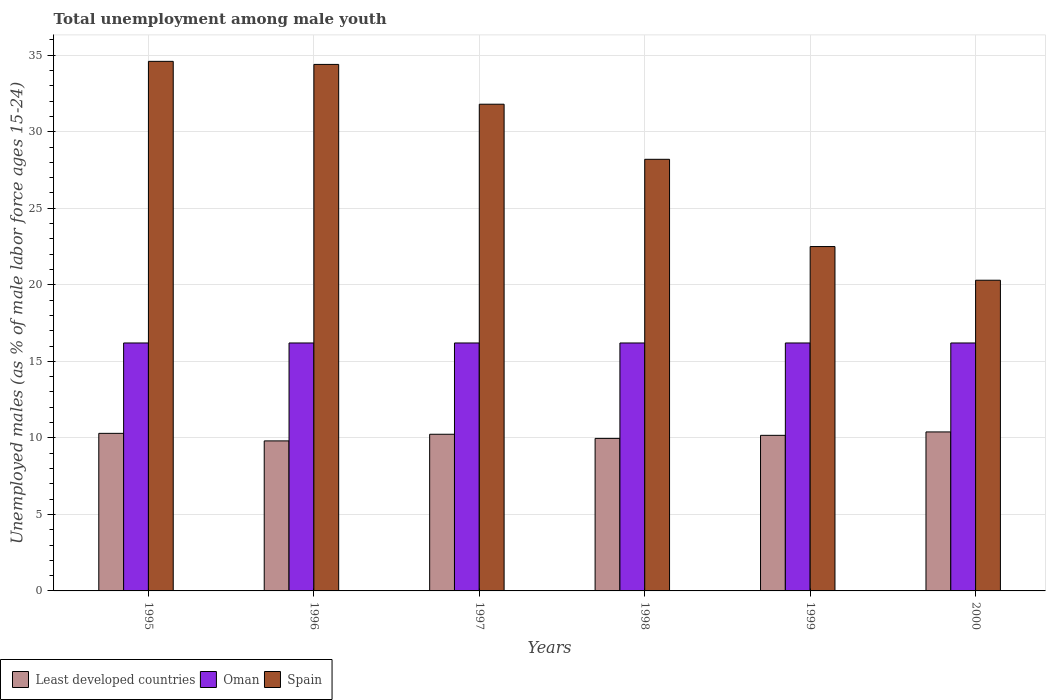What is the percentage of unemployed males in in Least developed countries in 1998?
Your answer should be compact. 9.97. Across all years, what is the maximum percentage of unemployed males in in Least developed countries?
Ensure brevity in your answer.  10.39. Across all years, what is the minimum percentage of unemployed males in in Least developed countries?
Offer a terse response. 9.8. What is the total percentage of unemployed males in in Oman in the graph?
Ensure brevity in your answer.  97.2. What is the difference between the percentage of unemployed males in in Least developed countries in 1995 and that in 2000?
Your response must be concise. -0.09. What is the difference between the percentage of unemployed males in in Oman in 1997 and the percentage of unemployed males in in Least developed countries in 1998?
Ensure brevity in your answer.  6.23. What is the average percentage of unemployed males in in Oman per year?
Your answer should be compact. 16.2. In the year 1996, what is the difference between the percentage of unemployed males in in Oman and percentage of unemployed males in in Least developed countries?
Your response must be concise. 6.4. In how many years, is the percentage of unemployed males in in Spain greater than 9 %?
Ensure brevity in your answer.  6. What is the ratio of the percentage of unemployed males in in Least developed countries in 1995 to that in 1998?
Provide a succinct answer. 1.03. Is the percentage of unemployed males in in Spain in 1997 less than that in 2000?
Your answer should be very brief. No. What is the difference between the highest and the second highest percentage of unemployed males in in Spain?
Provide a short and direct response. 0.2. What is the difference between the highest and the lowest percentage of unemployed males in in Least developed countries?
Your answer should be very brief. 0.59. Is the sum of the percentage of unemployed males in in Spain in 1998 and 2000 greater than the maximum percentage of unemployed males in in Oman across all years?
Your answer should be compact. Yes. What does the 2nd bar from the left in 1998 represents?
Make the answer very short. Oman. What does the 3rd bar from the right in 1999 represents?
Keep it short and to the point. Least developed countries. Does the graph contain grids?
Provide a succinct answer. Yes. How are the legend labels stacked?
Keep it short and to the point. Horizontal. What is the title of the graph?
Offer a very short reply. Total unemployment among male youth. Does "Rwanda" appear as one of the legend labels in the graph?
Your response must be concise. No. What is the label or title of the X-axis?
Your answer should be compact. Years. What is the label or title of the Y-axis?
Ensure brevity in your answer.  Unemployed males (as % of male labor force ages 15-24). What is the Unemployed males (as % of male labor force ages 15-24) in Least developed countries in 1995?
Offer a terse response. 10.3. What is the Unemployed males (as % of male labor force ages 15-24) in Oman in 1995?
Make the answer very short. 16.2. What is the Unemployed males (as % of male labor force ages 15-24) of Spain in 1995?
Offer a very short reply. 34.6. What is the Unemployed males (as % of male labor force ages 15-24) in Least developed countries in 1996?
Provide a succinct answer. 9.8. What is the Unemployed males (as % of male labor force ages 15-24) of Oman in 1996?
Make the answer very short. 16.2. What is the Unemployed males (as % of male labor force ages 15-24) in Spain in 1996?
Offer a terse response. 34.4. What is the Unemployed males (as % of male labor force ages 15-24) in Least developed countries in 1997?
Provide a succinct answer. 10.24. What is the Unemployed males (as % of male labor force ages 15-24) in Oman in 1997?
Provide a short and direct response. 16.2. What is the Unemployed males (as % of male labor force ages 15-24) of Spain in 1997?
Your answer should be very brief. 31.8. What is the Unemployed males (as % of male labor force ages 15-24) in Least developed countries in 1998?
Keep it short and to the point. 9.97. What is the Unemployed males (as % of male labor force ages 15-24) in Oman in 1998?
Ensure brevity in your answer.  16.2. What is the Unemployed males (as % of male labor force ages 15-24) of Spain in 1998?
Keep it short and to the point. 28.2. What is the Unemployed males (as % of male labor force ages 15-24) of Least developed countries in 1999?
Ensure brevity in your answer.  10.17. What is the Unemployed males (as % of male labor force ages 15-24) in Oman in 1999?
Offer a terse response. 16.2. What is the Unemployed males (as % of male labor force ages 15-24) in Least developed countries in 2000?
Ensure brevity in your answer.  10.39. What is the Unemployed males (as % of male labor force ages 15-24) of Oman in 2000?
Your response must be concise. 16.2. What is the Unemployed males (as % of male labor force ages 15-24) of Spain in 2000?
Your answer should be compact. 20.3. Across all years, what is the maximum Unemployed males (as % of male labor force ages 15-24) in Least developed countries?
Your answer should be very brief. 10.39. Across all years, what is the maximum Unemployed males (as % of male labor force ages 15-24) in Oman?
Keep it short and to the point. 16.2. Across all years, what is the maximum Unemployed males (as % of male labor force ages 15-24) in Spain?
Give a very brief answer. 34.6. Across all years, what is the minimum Unemployed males (as % of male labor force ages 15-24) in Least developed countries?
Provide a short and direct response. 9.8. Across all years, what is the minimum Unemployed males (as % of male labor force ages 15-24) in Oman?
Provide a succinct answer. 16.2. Across all years, what is the minimum Unemployed males (as % of male labor force ages 15-24) in Spain?
Provide a succinct answer. 20.3. What is the total Unemployed males (as % of male labor force ages 15-24) in Least developed countries in the graph?
Your answer should be very brief. 60.85. What is the total Unemployed males (as % of male labor force ages 15-24) in Oman in the graph?
Your response must be concise. 97.2. What is the total Unemployed males (as % of male labor force ages 15-24) in Spain in the graph?
Provide a short and direct response. 171.8. What is the difference between the Unemployed males (as % of male labor force ages 15-24) of Least developed countries in 1995 and that in 1996?
Ensure brevity in your answer.  0.49. What is the difference between the Unemployed males (as % of male labor force ages 15-24) in Oman in 1995 and that in 1996?
Provide a short and direct response. 0. What is the difference between the Unemployed males (as % of male labor force ages 15-24) of Least developed countries in 1995 and that in 1997?
Your answer should be compact. 0.06. What is the difference between the Unemployed males (as % of male labor force ages 15-24) in Oman in 1995 and that in 1997?
Your answer should be compact. 0. What is the difference between the Unemployed males (as % of male labor force ages 15-24) in Least developed countries in 1995 and that in 1998?
Your answer should be compact. 0.33. What is the difference between the Unemployed males (as % of male labor force ages 15-24) of Least developed countries in 1995 and that in 1999?
Your response must be concise. 0.13. What is the difference between the Unemployed males (as % of male labor force ages 15-24) in Spain in 1995 and that in 1999?
Give a very brief answer. 12.1. What is the difference between the Unemployed males (as % of male labor force ages 15-24) of Least developed countries in 1995 and that in 2000?
Keep it short and to the point. -0.09. What is the difference between the Unemployed males (as % of male labor force ages 15-24) in Spain in 1995 and that in 2000?
Give a very brief answer. 14.3. What is the difference between the Unemployed males (as % of male labor force ages 15-24) in Least developed countries in 1996 and that in 1997?
Offer a terse response. -0.43. What is the difference between the Unemployed males (as % of male labor force ages 15-24) in Oman in 1996 and that in 1997?
Keep it short and to the point. 0. What is the difference between the Unemployed males (as % of male labor force ages 15-24) in Spain in 1996 and that in 1997?
Keep it short and to the point. 2.6. What is the difference between the Unemployed males (as % of male labor force ages 15-24) in Least developed countries in 1996 and that in 1998?
Provide a short and direct response. -0.16. What is the difference between the Unemployed males (as % of male labor force ages 15-24) in Spain in 1996 and that in 1998?
Your response must be concise. 6.2. What is the difference between the Unemployed males (as % of male labor force ages 15-24) in Least developed countries in 1996 and that in 1999?
Your answer should be compact. -0.36. What is the difference between the Unemployed males (as % of male labor force ages 15-24) of Oman in 1996 and that in 1999?
Your response must be concise. 0. What is the difference between the Unemployed males (as % of male labor force ages 15-24) of Spain in 1996 and that in 1999?
Provide a short and direct response. 11.9. What is the difference between the Unemployed males (as % of male labor force ages 15-24) of Least developed countries in 1996 and that in 2000?
Give a very brief answer. -0.59. What is the difference between the Unemployed males (as % of male labor force ages 15-24) of Least developed countries in 1997 and that in 1998?
Offer a terse response. 0.27. What is the difference between the Unemployed males (as % of male labor force ages 15-24) in Spain in 1997 and that in 1998?
Your response must be concise. 3.6. What is the difference between the Unemployed males (as % of male labor force ages 15-24) of Least developed countries in 1997 and that in 1999?
Give a very brief answer. 0.07. What is the difference between the Unemployed males (as % of male labor force ages 15-24) in Oman in 1997 and that in 1999?
Ensure brevity in your answer.  0. What is the difference between the Unemployed males (as % of male labor force ages 15-24) of Spain in 1997 and that in 1999?
Keep it short and to the point. 9.3. What is the difference between the Unemployed males (as % of male labor force ages 15-24) of Least developed countries in 1997 and that in 2000?
Provide a short and direct response. -0.15. What is the difference between the Unemployed males (as % of male labor force ages 15-24) in Oman in 1997 and that in 2000?
Make the answer very short. 0. What is the difference between the Unemployed males (as % of male labor force ages 15-24) in Least developed countries in 1998 and that in 1999?
Provide a succinct answer. -0.2. What is the difference between the Unemployed males (as % of male labor force ages 15-24) of Oman in 1998 and that in 1999?
Your response must be concise. 0. What is the difference between the Unemployed males (as % of male labor force ages 15-24) of Spain in 1998 and that in 1999?
Your answer should be very brief. 5.7. What is the difference between the Unemployed males (as % of male labor force ages 15-24) in Least developed countries in 1998 and that in 2000?
Offer a terse response. -0.42. What is the difference between the Unemployed males (as % of male labor force ages 15-24) of Oman in 1998 and that in 2000?
Give a very brief answer. 0. What is the difference between the Unemployed males (as % of male labor force ages 15-24) of Spain in 1998 and that in 2000?
Make the answer very short. 7.9. What is the difference between the Unemployed males (as % of male labor force ages 15-24) of Least developed countries in 1999 and that in 2000?
Make the answer very short. -0.22. What is the difference between the Unemployed males (as % of male labor force ages 15-24) of Oman in 1999 and that in 2000?
Your answer should be compact. 0. What is the difference between the Unemployed males (as % of male labor force ages 15-24) of Spain in 1999 and that in 2000?
Offer a terse response. 2.2. What is the difference between the Unemployed males (as % of male labor force ages 15-24) in Least developed countries in 1995 and the Unemployed males (as % of male labor force ages 15-24) in Oman in 1996?
Give a very brief answer. -5.9. What is the difference between the Unemployed males (as % of male labor force ages 15-24) of Least developed countries in 1995 and the Unemployed males (as % of male labor force ages 15-24) of Spain in 1996?
Make the answer very short. -24.1. What is the difference between the Unemployed males (as % of male labor force ages 15-24) in Oman in 1995 and the Unemployed males (as % of male labor force ages 15-24) in Spain in 1996?
Make the answer very short. -18.2. What is the difference between the Unemployed males (as % of male labor force ages 15-24) of Least developed countries in 1995 and the Unemployed males (as % of male labor force ages 15-24) of Oman in 1997?
Ensure brevity in your answer.  -5.9. What is the difference between the Unemployed males (as % of male labor force ages 15-24) of Least developed countries in 1995 and the Unemployed males (as % of male labor force ages 15-24) of Spain in 1997?
Ensure brevity in your answer.  -21.5. What is the difference between the Unemployed males (as % of male labor force ages 15-24) of Oman in 1995 and the Unemployed males (as % of male labor force ages 15-24) of Spain in 1997?
Offer a very short reply. -15.6. What is the difference between the Unemployed males (as % of male labor force ages 15-24) of Least developed countries in 1995 and the Unemployed males (as % of male labor force ages 15-24) of Oman in 1998?
Ensure brevity in your answer.  -5.9. What is the difference between the Unemployed males (as % of male labor force ages 15-24) in Least developed countries in 1995 and the Unemployed males (as % of male labor force ages 15-24) in Spain in 1998?
Your answer should be very brief. -17.9. What is the difference between the Unemployed males (as % of male labor force ages 15-24) of Oman in 1995 and the Unemployed males (as % of male labor force ages 15-24) of Spain in 1998?
Offer a terse response. -12. What is the difference between the Unemployed males (as % of male labor force ages 15-24) of Least developed countries in 1995 and the Unemployed males (as % of male labor force ages 15-24) of Oman in 1999?
Your response must be concise. -5.9. What is the difference between the Unemployed males (as % of male labor force ages 15-24) in Least developed countries in 1995 and the Unemployed males (as % of male labor force ages 15-24) in Spain in 1999?
Offer a terse response. -12.2. What is the difference between the Unemployed males (as % of male labor force ages 15-24) of Least developed countries in 1995 and the Unemployed males (as % of male labor force ages 15-24) of Oman in 2000?
Your answer should be compact. -5.9. What is the difference between the Unemployed males (as % of male labor force ages 15-24) in Least developed countries in 1995 and the Unemployed males (as % of male labor force ages 15-24) in Spain in 2000?
Ensure brevity in your answer.  -10. What is the difference between the Unemployed males (as % of male labor force ages 15-24) in Oman in 1995 and the Unemployed males (as % of male labor force ages 15-24) in Spain in 2000?
Provide a short and direct response. -4.1. What is the difference between the Unemployed males (as % of male labor force ages 15-24) of Least developed countries in 1996 and the Unemployed males (as % of male labor force ages 15-24) of Oman in 1997?
Provide a succinct answer. -6.4. What is the difference between the Unemployed males (as % of male labor force ages 15-24) in Least developed countries in 1996 and the Unemployed males (as % of male labor force ages 15-24) in Spain in 1997?
Offer a very short reply. -22. What is the difference between the Unemployed males (as % of male labor force ages 15-24) in Oman in 1996 and the Unemployed males (as % of male labor force ages 15-24) in Spain in 1997?
Offer a terse response. -15.6. What is the difference between the Unemployed males (as % of male labor force ages 15-24) of Least developed countries in 1996 and the Unemployed males (as % of male labor force ages 15-24) of Oman in 1998?
Offer a terse response. -6.4. What is the difference between the Unemployed males (as % of male labor force ages 15-24) of Least developed countries in 1996 and the Unemployed males (as % of male labor force ages 15-24) of Spain in 1998?
Provide a succinct answer. -18.4. What is the difference between the Unemployed males (as % of male labor force ages 15-24) in Oman in 1996 and the Unemployed males (as % of male labor force ages 15-24) in Spain in 1998?
Provide a short and direct response. -12. What is the difference between the Unemployed males (as % of male labor force ages 15-24) in Least developed countries in 1996 and the Unemployed males (as % of male labor force ages 15-24) in Oman in 1999?
Offer a terse response. -6.4. What is the difference between the Unemployed males (as % of male labor force ages 15-24) in Least developed countries in 1996 and the Unemployed males (as % of male labor force ages 15-24) in Spain in 1999?
Your response must be concise. -12.7. What is the difference between the Unemployed males (as % of male labor force ages 15-24) of Oman in 1996 and the Unemployed males (as % of male labor force ages 15-24) of Spain in 1999?
Offer a very short reply. -6.3. What is the difference between the Unemployed males (as % of male labor force ages 15-24) of Least developed countries in 1996 and the Unemployed males (as % of male labor force ages 15-24) of Oman in 2000?
Give a very brief answer. -6.4. What is the difference between the Unemployed males (as % of male labor force ages 15-24) in Least developed countries in 1996 and the Unemployed males (as % of male labor force ages 15-24) in Spain in 2000?
Make the answer very short. -10.5. What is the difference between the Unemployed males (as % of male labor force ages 15-24) in Least developed countries in 1997 and the Unemployed males (as % of male labor force ages 15-24) in Oman in 1998?
Provide a short and direct response. -5.96. What is the difference between the Unemployed males (as % of male labor force ages 15-24) in Least developed countries in 1997 and the Unemployed males (as % of male labor force ages 15-24) in Spain in 1998?
Provide a succinct answer. -17.96. What is the difference between the Unemployed males (as % of male labor force ages 15-24) in Least developed countries in 1997 and the Unemployed males (as % of male labor force ages 15-24) in Oman in 1999?
Your answer should be compact. -5.96. What is the difference between the Unemployed males (as % of male labor force ages 15-24) in Least developed countries in 1997 and the Unemployed males (as % of male labor force ages 15-24) in Spain in 1999?
Your answer should be compact. -12.26. What is the difference between the Unemployed males (as % of male labor force ages 15-24) of Oman in 1997 and the Unemployed males (as % of male labor force ages 15-24) of Spain in 1999?
Keep it short and to the point. -6.3. What is the difference between the Unemployed males (as % of male labor force ages 15-24) in Least developed countries in 1997 and the Unemployed males (as % of male labor force ages 15-24) in Oman in 2000?
Offer a terse response. -5.96. What is the difference between the Unemployed males (as % of male labor force ages 15-24) of Least developed countries in 1997 and the Unemployed males (as % of male labor force ages 15-24) of Spain in 2000?
Keep it short and to the point. -10.06. What is the difference between the Unemployed males (as % of male labor force ages 15-24) in Least developed countries in 1998 and the Unemployed males (as % of male labor force ages 15-24) in Oman in 1999?
Your answer should be very brief. -6.23. What is the difference between the Unemployed males (as % of male labor force ages 15-24) of Least developed countries in 1998 and the Unemployed males (as % of male labor force ages 15-24) of Spain in 1999?
Offer a very short reply. -12.53. What is the difference between the Unemployed males (as % of male labor force ages 15-24) of Oman in 1998 and the Unemployed males (as % of male labor force ages 15-24) of Spain in 1999?
Keep it short and to the point. -6.3. What is the difference between the Unemployed males (as % of male labor force ages 15-24) of Least developed countries in 1998 and the Unemployed males (as % of male labor force ages 15-24) of Oman in 2000?
Your answer should be compact. -6.23. What is the difference between the Unemployed males (as % of male labor force ages 15-24) of Least developed countries in 1998 and the Unemployed males (as % of male labor force ages 15-24) of Spain in 2000?
Ensure brevity in your answer.  -10.33. What is the difference between the Unemployed males (as % of male labor force ages 15-24) in Oman in 1998 and the Unemployed males (as % of male labor force ages 15-24) in Spain in 2000?
Your response must be concise. -4.1. What is the difference between the Unemployed males (as % of male labor force ages 15-24) of Least developed countries in 1999 and the Unemployed males (as % of male labor force ages 15-24) of Oman in 2000?
Your response must be concise. -6.03. What is the difference between the Unemployed males (as % of male labor force ages 15-24) of Least developed countries in 1999 and the Unemployed males (as % of male labor force ages 15-24) of Spain in 2000?
Give a very brief answer. -10.13. What is the average Unemployed males (as % of male labor force ages 15-24) of Least developed countries per year?
Your response must be concise. 10.14. What is the average Unemployed males (as % of male labor force ages 15-24) in Spain per year?
Your response must be concise. 28.63. In the year 1995, what is the difference between the Unemployed males (as % of male labor force ages 15-24) in Least developed countries and Unemployed males (as % of male labor force ages 15-24) in Oman?
Keep it short and to the point. -5.9. In the year 1995, what is the difference between the Unemployed males (as % of male labor force ages 15-24) in Least developed countries and Unemployed males (as % of male labor force ages 15-24) in Spain?
Give a very brief answer. -24.3. In the year 1995, what is the difference between the Unemployed males (as % of male labor force ages 15-24) in Oman and Unemployed males (as % of male labor force ages 15-24) in Spain?
Offer a very short reply. -18.4. In the year 1996, what is the difference between the Unemployed males (as % of male labor force ages 15-24) in Least developed countries and Unemployed males (as % of male labor force ages 15-24) in Oman?
Keep it short and to the point. -6.4. In the year 1996, what is the difference between the Unemployed males (as % of male labor force ages 15-24) of Least developed countries and Unemployed males (as % of male labor force ages 15-24) of Spain?
Your answer should be compact. -24.6. In the year 1996, what is the difference between the Unemployed males (as % of male labor force ages 15-24) of Oman and Unemployed males (as % of male labor force ages 15-24) of Spain?
Your response must be concise. -18.2. In the year 1997, what is the difference between the Unemployed males (as % of male labor force ages 15-24) in Least developed countries and Unemployed males (as % of male labor force ages 15-24) in Oman?
Ensure brevity in your answer.  -5.96. In the year 1997, what is the difference between the Unemployed males (as % of male labor force ages 15-24) in Least developed countries and Unemployed males (as % of male labor force ages 15-24) in Spain?
Ensure brevity in your answer.  -21.56. In the year 1997, what is the difference between the Unemployed males (as % of male labor force ages 15-24) of Oman and Unemployed males (as % of male labor force ages 15-24) of Spain?
Keep it short and to the point. -15.6. In the year 1998, what is the difference between the Unemployed males (as % of male labor force ages 15-24) of Least developed countries and Unemployed males (as % of male labor force ages 15-24) of Oman?
Offer a terse response. -6.23. In the year 1998, what is the difference between the Unemployed males (as % of male labor force ages 15-24) of Least developed countries and Unemployed males (as % of male labor force ages 15-24) of Spain?
Provide a short and direct response. -18.23. In the year 1999, what is the difference between the Unemployed males (as % of male labor force ages 15-24) in Least developed countries and Unemployed males (as % of male labor force ages 15-24) in Oman?
Provide a short and direct response. -6.03. In the year 1999, what is the difference between the Unemployed males (as % of male labor force ages 15-24) of Least developed countries and Unemployed males (as % of male labor force ages 15-24) of Spain?
Your answer should be compact. -12.33. In the year 2000, what is the difference between the Unemployed males (as % of male labor force ages 15-24) of Least developed countries and Unemployed males (as % of male labor force ages 15-24) of Oman?
Provide a short and direct response. -5.81. In the year 2000, what is the difference between the Unemployed males (as % of male labor force ages 15-24) in Least developed countries and Unemployed males (as % of male labor force ages 15-24) in Spain?
Make the answer very short. -9.91. In the year 2000, what is the difference between the Unemployed males (as % of male labor force ages 15-24) in Oman and Unemployed males (as % of male labor force ages 15-24) in Spain?
Your response must be concise. -4.1. What is the ratio of the Unemployed males (as % of male labor force ages 15-24) of Least developed countries in 1995 to that in 1996?
Your answer should be very brief. 1.05. What is the ratio of the Unemployed males (as % of male labor force ages 15-24) in Spain in 1995 to that in 1996?
Provide a short and direct response. 1.01. What is the ratio of the Unemployed males (as % of male labor force ages 15-24) of Oman in 1995 to that in 1997?
Offer a very short reply. 1. What is the ratio of the Unemployed males (as % of male labor force ages 15-24) in Spain in 1995 to that in 1997?
Keep it short and to the point. 1.09. What is the ratio of the Unemployed males (as % of male labor force ages 15-24) of Least developed countries in 1995 to that in 1998?
Offer a very short reply. 1.03. What is the ratio of the Unemployed males (as % of male labor force ages 15-24) of Oman in 1995 to that in 1998?
Offer a terse response. 1. What is the ratio of the Unemployed males (as % of male labor force ages 15-24) in Spain in 1995 to that in 1998?
Provide a succinct answer. 1.23. What is the ratio of the Unemployed males (as % of male labor force ages 15-24) in Least developed countries in 1995 to that in 1999?
Keep it short and to the point. 1.01. What is the ratio of the Unemployed males (as % of male labor force ages 15-24) of Oman in 1995 to that in 1999?
Provide a succinct answer. 1. What is the ratio of the Unemployed males (as % of male labor force ages 15-24) of Spain in 1995 to that in 1999?
Your answer should be very brief. 1.54. What is the ratio of the Unemployed males (as % of male labor force ages 15-24) of Least developed countries in 1995 to that in 2000?
Make the answer very short. 0.99. What is the ratio of the Unemployed males (as % of male labor force ages 15-24) of Spain in 1995 to that in 2000?
Give a very brief answer. 1.7. What is the ratio of the Unemployed males (as % of male labor force ages 15-24) in Least developed countries in 1996 to that in 1997?
Keep it short and to the point. 0.96. What is the ratio of the Unemployed males (as % of male labor force ages 15-24) in Oman in 1996 to that in 1997?
Provide a succinct answer. 1. What is the ratio of the Unemployed males (as % of male labor force ages 15-24) of Spain in 1996 to that in 1997?
Make the answer very short. 1.08. What is the ratio of the Unemployed males (as % of male labor force ages 15-24) in Least developed countries in 1996 to that in 1998?
Offer a terse response. 0.98. What is the ratio of the Unemployed males (as % of male labor force ages 15-24) of Spain in 1996 to that in 1998?
Ensure brevity in your answer.  1.22. What is the ratio of the Unemployed males (as % of male labor force ages 15-24) in Least developed countries in 1996 to that in 1999?
Your response must be concise. 0.96. What is the ratio of the Unemployed males (as % of male labor force ages 15-24) of Oman in 1996 to that in 1999?
Your response must be concise. 1. What is the ratio of the Unemployed males (as % of male labor force ages 15-24) of Spain in 1996 to that in 1999?
Make the answer very short. 1.53. What is the ratio of the Unemployed males (as % of male labor force ages 15-24) of Least developed countries in 1996 to that in 2000?
Your response must be concise. 0.94. What is the ratio of the Unemployed males (as % of male labor force ages 15-24) of Oman in 1996 to that in 2000?
Provide a short and direct response. 1. What is the ratio of the Unemployed males (as % of male labor force ages 15-24) of Spain in 1996 to that in 2000?
Provide a succinct answer. 1.69. What is the ratio of the Unemployed males (as % of male labor force ages 15-24) of Least developed countries in 1997 to that in 1998?
Your answer should be compact. 1.03. What is the ratio of the Unemployed males (as % of male labor force ages 15-24) of Spain in 1997 to that in 1998?
Your answer should be compact. 1.13. What is the ratio of the Unemployed males (as % of male labor force ages 15-24) of Least developed countries in 1997 to that in 1999?
Provide a short and direct response. 1.01. What is the ratio of the Unemployed males (as % of male labor force ages 15-24) in Spain in 1997 to that in 1999?
Offer a very short reply. 1.41. What is the ratio of the Unemployed males (as % of male labor force ages 15-24) in Least developed countries in 1997 to that in 2000?
Make the answer very short. 0.99. What is the ratio of the Unemployed males (as % of male labor force ages 15-24) of Spain in 1997 to that in 2000?
Offer a terse response. 1.57. What is the ratio of the Unemployed males (as % of male labor force ages 15-24) of Least developed countries in 1998 to that in 1999?
Give a very brief answer. 0.98. What is the ratio of the Unemployed males (as % of male labor force ages 15-24) in Spain in 1998 to that in 1999?
Your response must be concise. 1.25. What is the ratio of the Unemployed males (as % of male labor force ages 15-24) in Least developed countries in 1998 to that in 2000?
Offer a very short reply. 0.96. What is the ratio of the Unemployed males (as % of male labor force ages 15-24) in Oman in 1998 to that in 2000?
Your answer should be very brief. 1. What is the ratio of the Unemployed males (as % of male labor force ages 15-24) of Spain in 1998 to that in 2000?
Keep it short and to the point. 1.39. What is the ratio of the Unemployed males (as % of male labor force ages 15-24) in Least developed countries in 1999 to that in 2000?
Your answer should be compact. 0.98. What is the ratio of the Unemployed males (as % of male labor force ages 15-24) in Oman in 1999 to that in 2000?
Ensure brevity in your answer.  1. What is the ratio of the Unemployed males (as % of male labor force ages 15-24) of Spain in 1999 to that in 2000?
Keep it short and to the point. 1.11. What is the difference between the highest and the second highest Unemployed males (as % of male labor force ages 15-24) in Least developed countries?
Make the answer very short. 0.09. What is the difference between the highest and the lowest Unemployed males (as % of male labor force ages 15-24) of Least developed countries?
Provide a short and direct response. 0.59. What is the difference between the highest and the lowest Unemployed males (as % of male labor force ages 15-24) in Oman?
Your response must be concise. 0. 